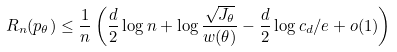<formula> <loc_0><loc_0><loc_500><loc_500>R _ { n } ( p _ { \theta } ) \leq \frac { 1 } { n } \left ( \frac { d } { 2 } \log { n } + \log { \frac { \sqrt { J _ { \theta } } } { w ( \theta ) } } - \frac { d } { 2 } \log { c _ { d } / e } + o ( 1 ) \right )</formula> 